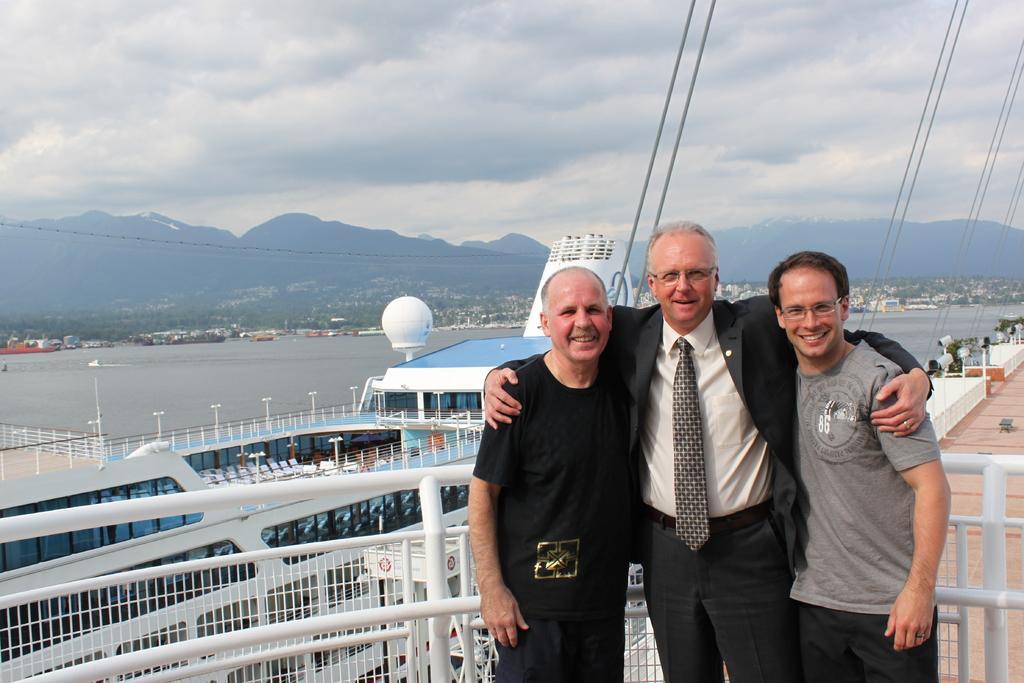Can you describe this image briefly? In this image I can see there are three persons standing in front of the fence and they are smiling and at the top I can see the sky and cable wires and lake and ship and the hill 